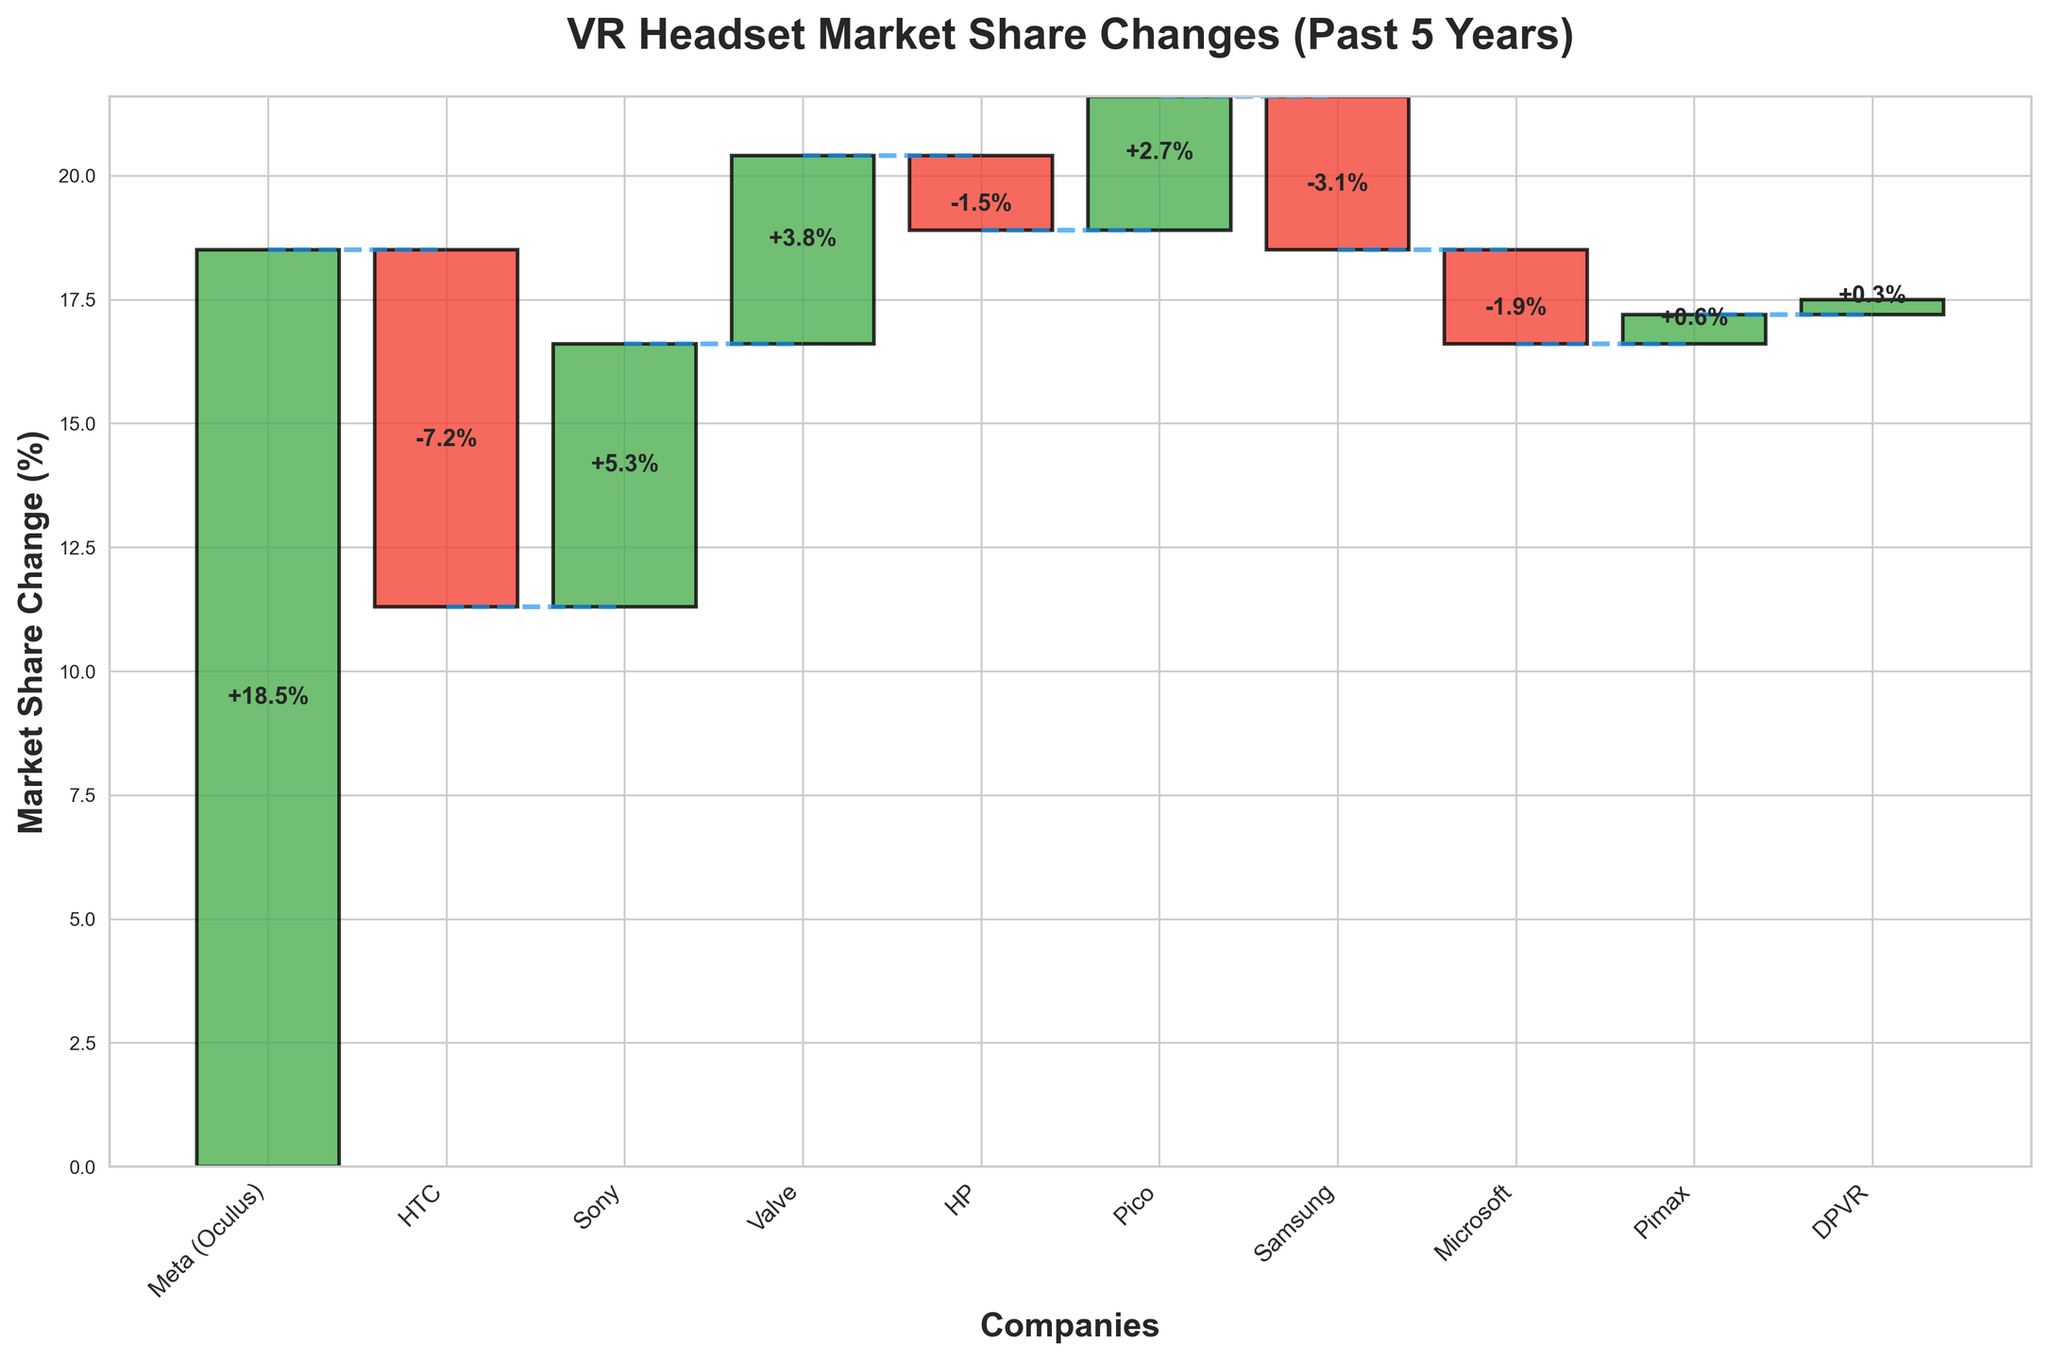How many companies are represented in the chart? The x-axis lists the companies, and there are ten different labels.
Answer: 10 Which company experienced the highest gain in market share? Meta (Oculus) has the highest positive bar with a gain of +18.5%.
Answer: Meta (Oculus) How did HTC's market share change over the past 5 years? HTC has a negative bar with a change of -7.2%, indicating a loss.
Answer: -7.2% What's the total market share change for companies with losses? HTC (-7.2), HP (-1.5), Samsung (-3.1), and Microsoft (-1.9) have losses. Sum them: -7.2 + -1.5 + -3.1 + -1.9 = -13.7.
Answer: -13.7% Which company had a market share change closest to zero? DPVR has a small positive change of +0.3%, which is the closest to zero among all companies.
Answer: DPVR What is the difference in market share change between Sony and HTC? Sony gained +5.3%, while HTC lost -7.2%. The difference is 5.3 - (-7.2) = 12.5.
Answer: 12.5% Which company had a larger market share gain, Valve or Pico? Valve gained +3.8%, while Pico gained +2.7%. Comparing the two, Valve's gain is larger.
Answer: Valve What is the cumulative market share change after Sony's change? Meta (Oculus) +18.5, HTC -7.2, Sony +5.3. The cumulative change is 18.5 - 7.2 + 5.3 = 16.6.
Answer: +16.6% What's the average market share change across all companies? Sum of all changes: 18.5 - 7.2 + 5.3 + 3.8 - 1.5 + 2.7 - 3.1 - 1.9 + 0.6 + 0.3 = 17.5. Average is 17.5 / 10 = 1.75.
Answer: 1.75% Which company had a larger market share loss, Samsung or HP? Samsung lost -3.1%, while HP lost -1.5%. Comparing the two, Samsung's loss is larger.
Answer: Samsung 